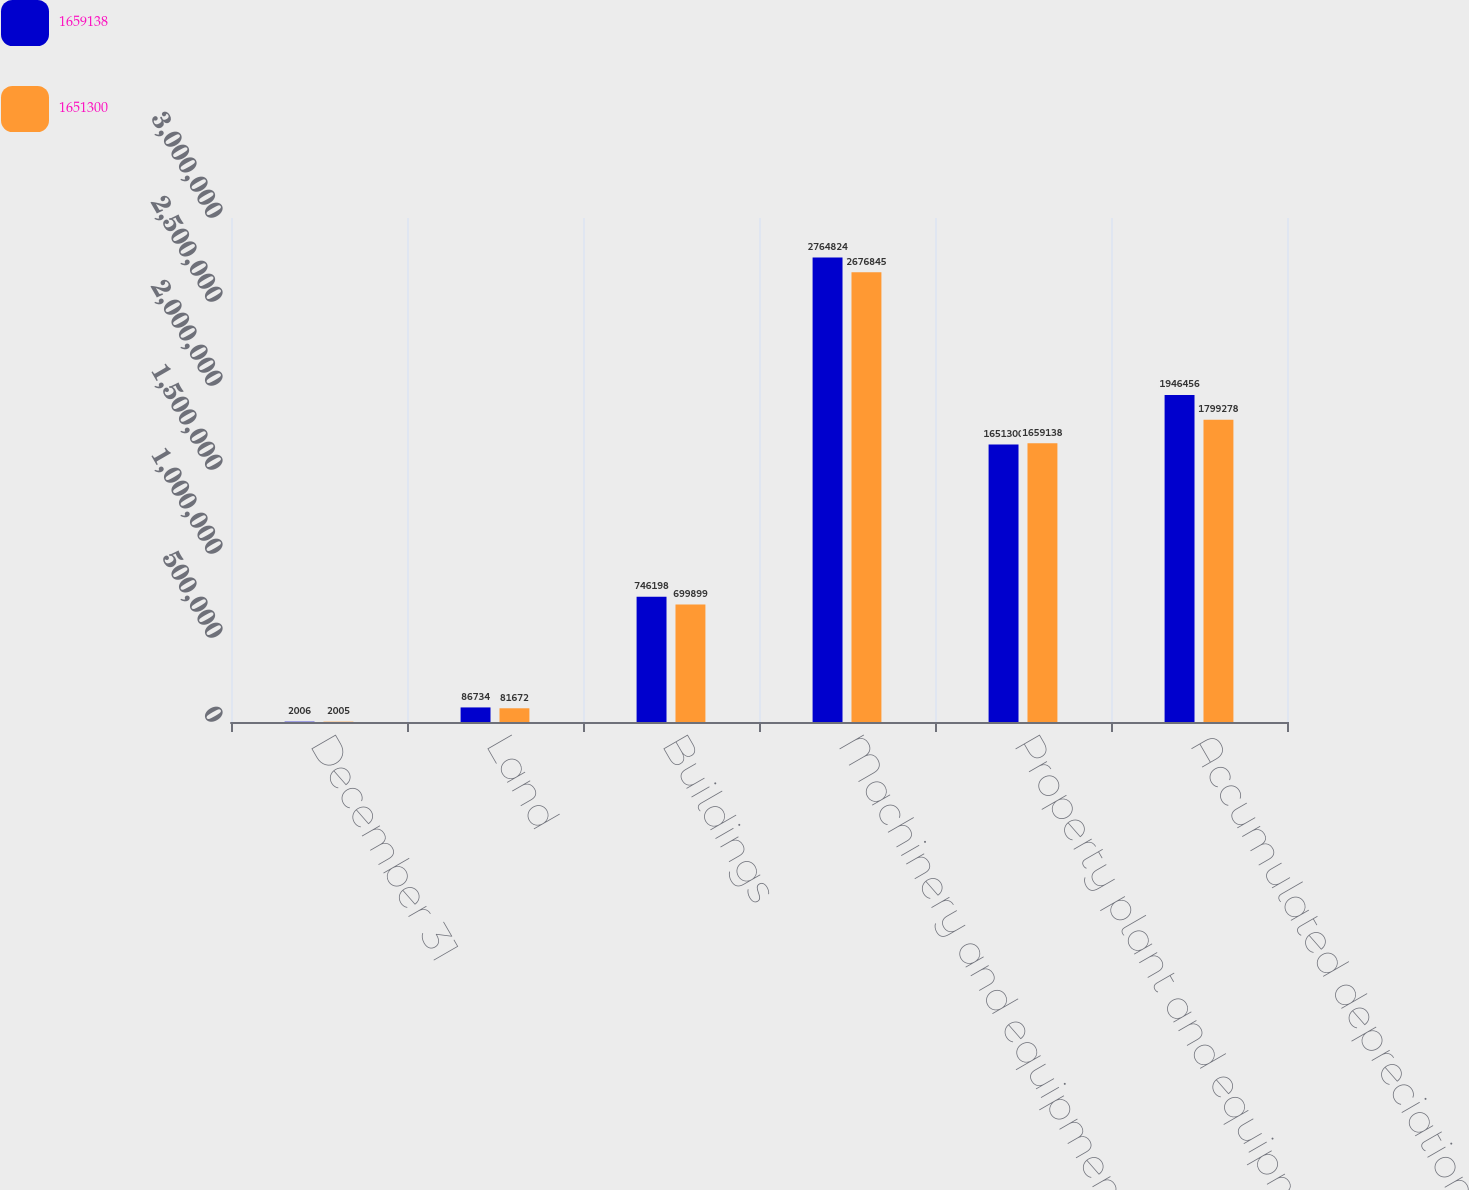Convert chart. <chart><loc_0><loc_0><loc_500><loc_500><stacked_bar_chart><ecel><fcel>December 31<fcel>Land<fcel>Buildings<fcel>Machinery and equipment<fcel>Property plant and equipment<fcel>Accumulated depreciation<nl><fcel>1.65914e+06<fcel>2006<fcel>86734<fcel>746198<fcel>2.76482e+06<fcel>1.6513e+06<fcel>1.94646e+06<nl><fcel>1.6513e+06<fcel>2005<fcel>81672<fcel>699899<fcel>2.67684e+06<fcel>1.65914e+06<fcel>1.79928e+06<nl></chart> 